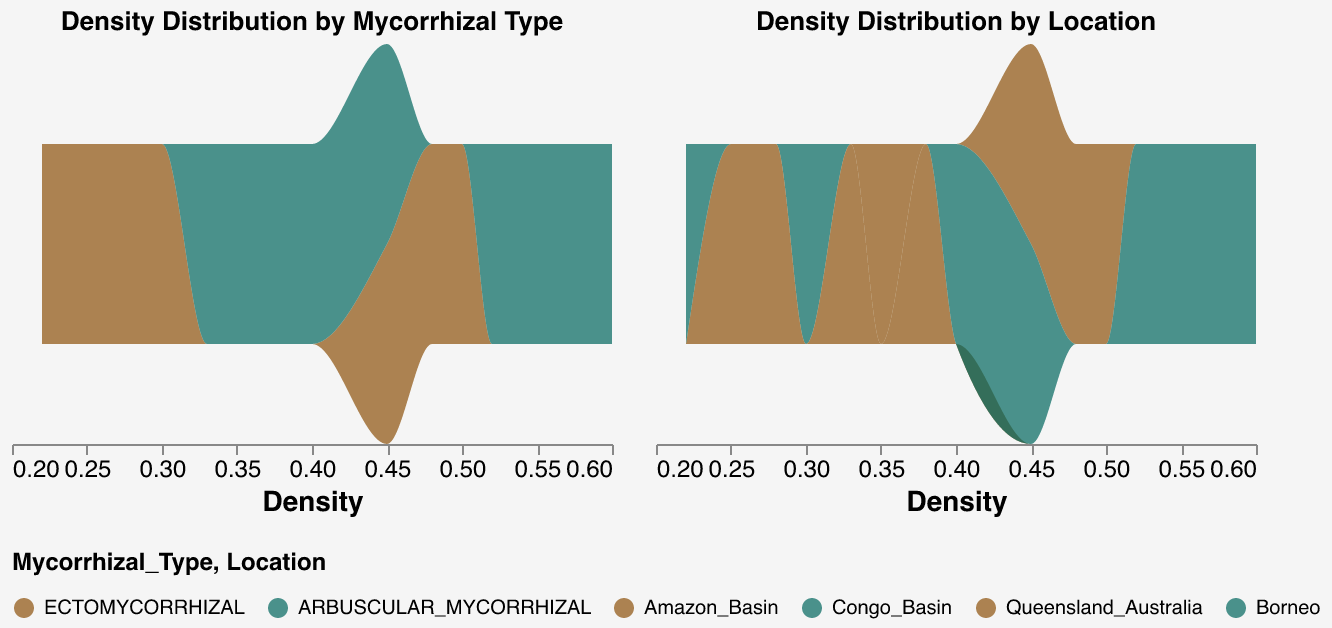What are the titles of the subplots? The first subplot has the title "Density Distribution by Mycorrhizal Type" and the second subplot is titled "Density Distribution by Location".
Answer: "Density Distribution by Mycorrhizal Type", "Density Distribution by Location" Which mycorrhizal type appears more frequently overall? The density plot shows that ARBUSCULAR_MYCORRHIZAL has a broader and more frequent density distribution compared to ECTOMYCORRHIZAL.
Answer: ARBUSCULAR_MYCORRHIZAL Which location has the highest density count? By examining the density plot for each location, Congo_Basin shows the highest density count across its density distribution.
Answer: Congo_Basin What is the range of densities observed for ECTOMYCORRHIZAL fungi? The density values for ECTOMYCORRHIZAL fungi range from 0.22 to 0.50, as seen in the distribution on the density plot.
Answer: 0.22 to 0.50 Which plant family is associated with both mycorrhizal types? By looking at the legend and density distributions, the plant family Leguminosae is associated with ARBUSCULAR_MYCORRHIZAL in Congo_Basin and ECTOMYCORRHIZAL is not associated with this plant family.
Answer: Leguminosae How does the density distribution of Amazon_Basin compare to Queensland_Australia? The Amazon_Basin shows a higher density overall, with a broad, relatively high distribution, whereas Queensland_Australia has narrower, lower-density peaks.
Answer: Amazon_Basin is higher What is the most common density value for ARBUSCULAR_MYCORRHIZAL fungi? The most common density value can be observed where the green plot peaks; it is around 0.45.
Answer: Around 0.45 Is there a location that has a similar density range for both mycorrhizal types? Both Amazon_Basin and Queensland_Australia show a similar density range for ECTOMYCORRHIZAL and ARBUSCULAR_MYCORRHIZAL in their respective distributions.
Answer: Amazon_Basin, Queensland_Australia 